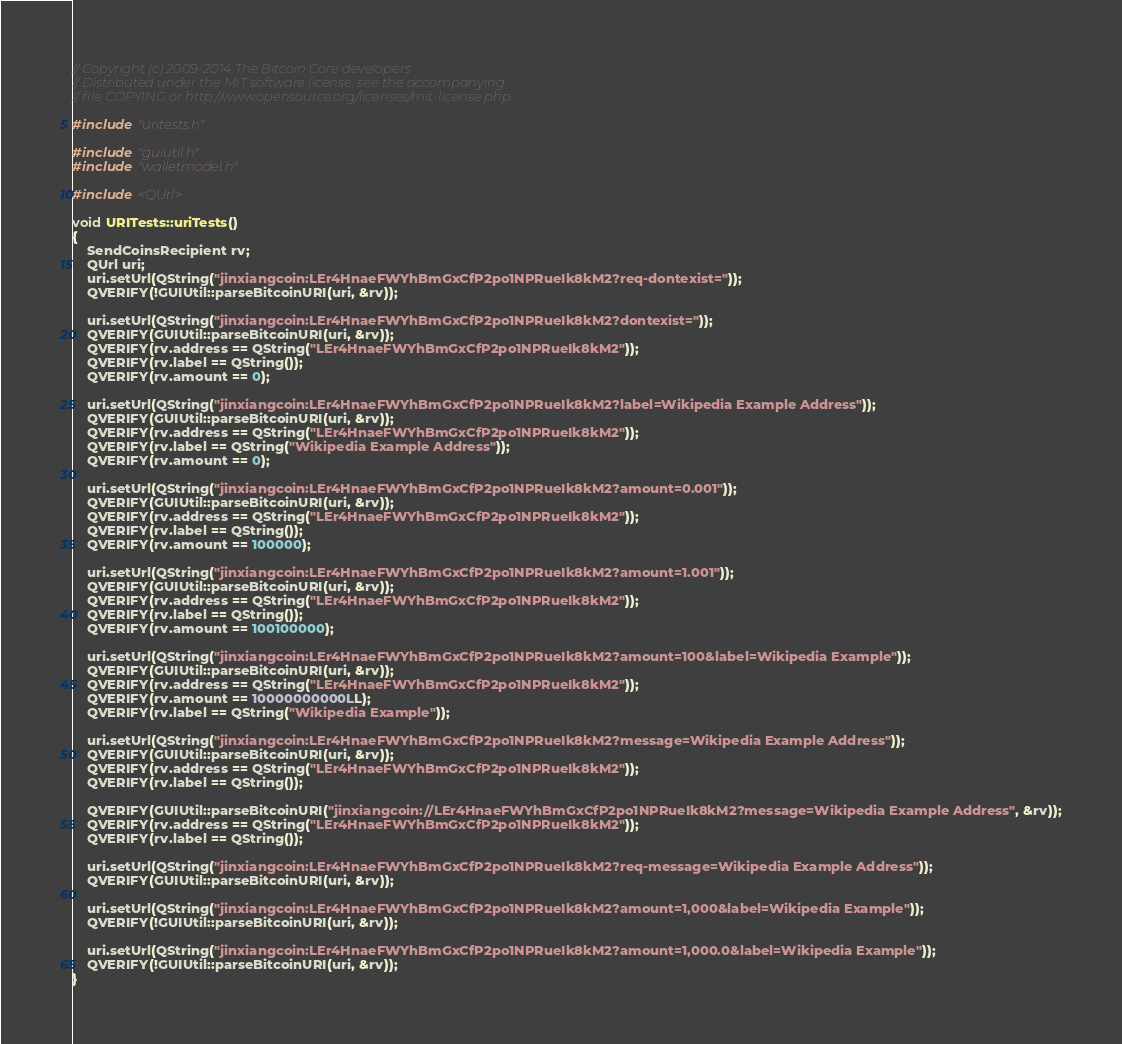Convert code to text. <code><loc_0><loc_0><loc_500><loc_500><_C++_>// Copyright (c) 2009-2014 The Bitcoin Core developers
// Distributed under the MIT software license, see the accompanying
// file COPYING or http://www.opensource.org/licenses/mit-license.php.

#include "uritests.h"

#include "guiutil.h"
#include "walletmodel.h"

#include <QUrl>

void URITests::uriTests()
{
    SendCoinsRecipient rv;
    QUrl uri;
    uri.setUrl(QString("jinxiangcoin:LEr4HnaeFWYhBmGxCfP2po1NPRueIk8kM2?req-dontexist="));
    QVERIFY(!GUIUtil::parseBitcoinURI(uri, &rv));

    uri.setUrl(QString("jinxiangcoin:LEr4HnaeFWYhBmGxCfP2po1NPRueIk8kM2?dontexist="));
    QVERIFY(GUIUtil::parseBitcoinURI(uri, &rv));
    QVERIFY(rv.address == QString("LEr4HnaeFWYhBmGxCfP2po1NPRueIk8kM2"));
    QVERIFY(rv.label == QString());
    QVERIFY(rv.amount == 0);

    uri.setUrl(QString("jinxiangcoin:LEr4HnaeFWYhBmGxCfP2po1NPRueIk8kM2?label=Wikipedia Example Address"));
    QVERIFY(GUIUtil::parseBitcoinURI(uri, &rv));
    QVERIFY(rv.address == QString("LEr4HnaeFWYhBmGxCfP2po1NPRueIk8kM2"));
    QVERIFY(rv.label == QString("Wikipedia Example Address"));
    QVERIFY(rv.amount == 0);

    uri.setUrl(QString("jinxiangcoin:LEr4HnaeFWYhBmGxCfP2po1NPRueIk8kM2?amount=0.001"));
    QVERIFY(GUIUtil::parseBitcoinURI(uri, &rv));
    QVERIFY(rv.address == QString("LEr4HnaeFWYhBmGxCfP2po1NPRueIk8kM2"));
    QVERIFY(rv.label == QString());
    QVERIFY(rv.amount == 100000);

    uri.setUrl(QString("jinxiangcoin:LEr4HnaeFWYhBmGxCfP2po1NPRueIk8kM2?amount=1.001"));
    QVERIFY(GUIUtil::parseBitcoinURI(uri, &rv));
    QVERIFY(rv.address == QString("LEr4HnaeFWYhBmGxCfP2po1NPRueIk8kM2"));
    QVERIFY(rv.label == QString());
    QVERIFY(rv.amount == 100100000);

    uri.setUrl(QString("jinxiangcoin:LEr4HnaeFWYhBmGxCfP2po1NPRueIk8kM2?amount=100&label=Wikipedia Example"));
    QVERIFY(GUIUtil::parseBitcoinURI(uri, &rv));
    QVERIFY(rv.address == QString("LEr4HnaeFWYhBmGxCfP2po1NPRueIk8kM2"));
    QVERIFY(rv.amount == 10000000000LL);
    QVERIFY(rv.label == QString("Wikipedia Example"));

    uri.setUrl(QString("jinxiangcoin:LEr4HnaeFWYhBmGxCfP2po1NPRueIk8kM2?message=Wikipedia Example Address"));
    QVERIFY(GUIUtil::parseBitcoinURI(uri, &rv));
    QVERIFY(rv.address == QString("LEr4HnaeFWYhBmGxCfP2po1NPRueIk8kM2"));
    QVERIFY(rv.label == QString());

    QVERIFY(GUIUtil::parseBitcoinURI("jinxiangcoin://LEr4HnaeFWYhBmGxCfP2po1NPRueIk8kM2?message=Wikipedia Example Address", &rv));
    QVERIFY(rv.address == QString("LEr4HnaeFWYhBmGxCfP2po1NPRueIk8kM2"));
    QVERIFY(rv.label == QString());

    uri.setUrl(QString("jinxiangcoin:LEr4HnaeFWYhBmGxCfP2po1NPRueIk8kM2?req-message=Wikipedia Example Address"));
    QVERIFY(GUIUtil::parseBitcoinURI(uri, &rv));

    uri.setUrl(QString("jinxiangcoin:LEr4HnaeFWYhBmGxCfP2po1NPRueIk8kM2?amount=1,000&label=Wikipedia Example"));
    QVERIFY(!GUIUtil::parseBitcoinURI(uri, &rv));

    uri.setUrl(QString("jinxiangcoin:LEr4HnaeFWYhBmGxCfP2po1NPRueIk8kM2?amount=1,000.0&label=Wikipedia Example"));
    QVERIFY(!GUIUtil::parseBitcoinURI(uri, &rv));
}
</code> 